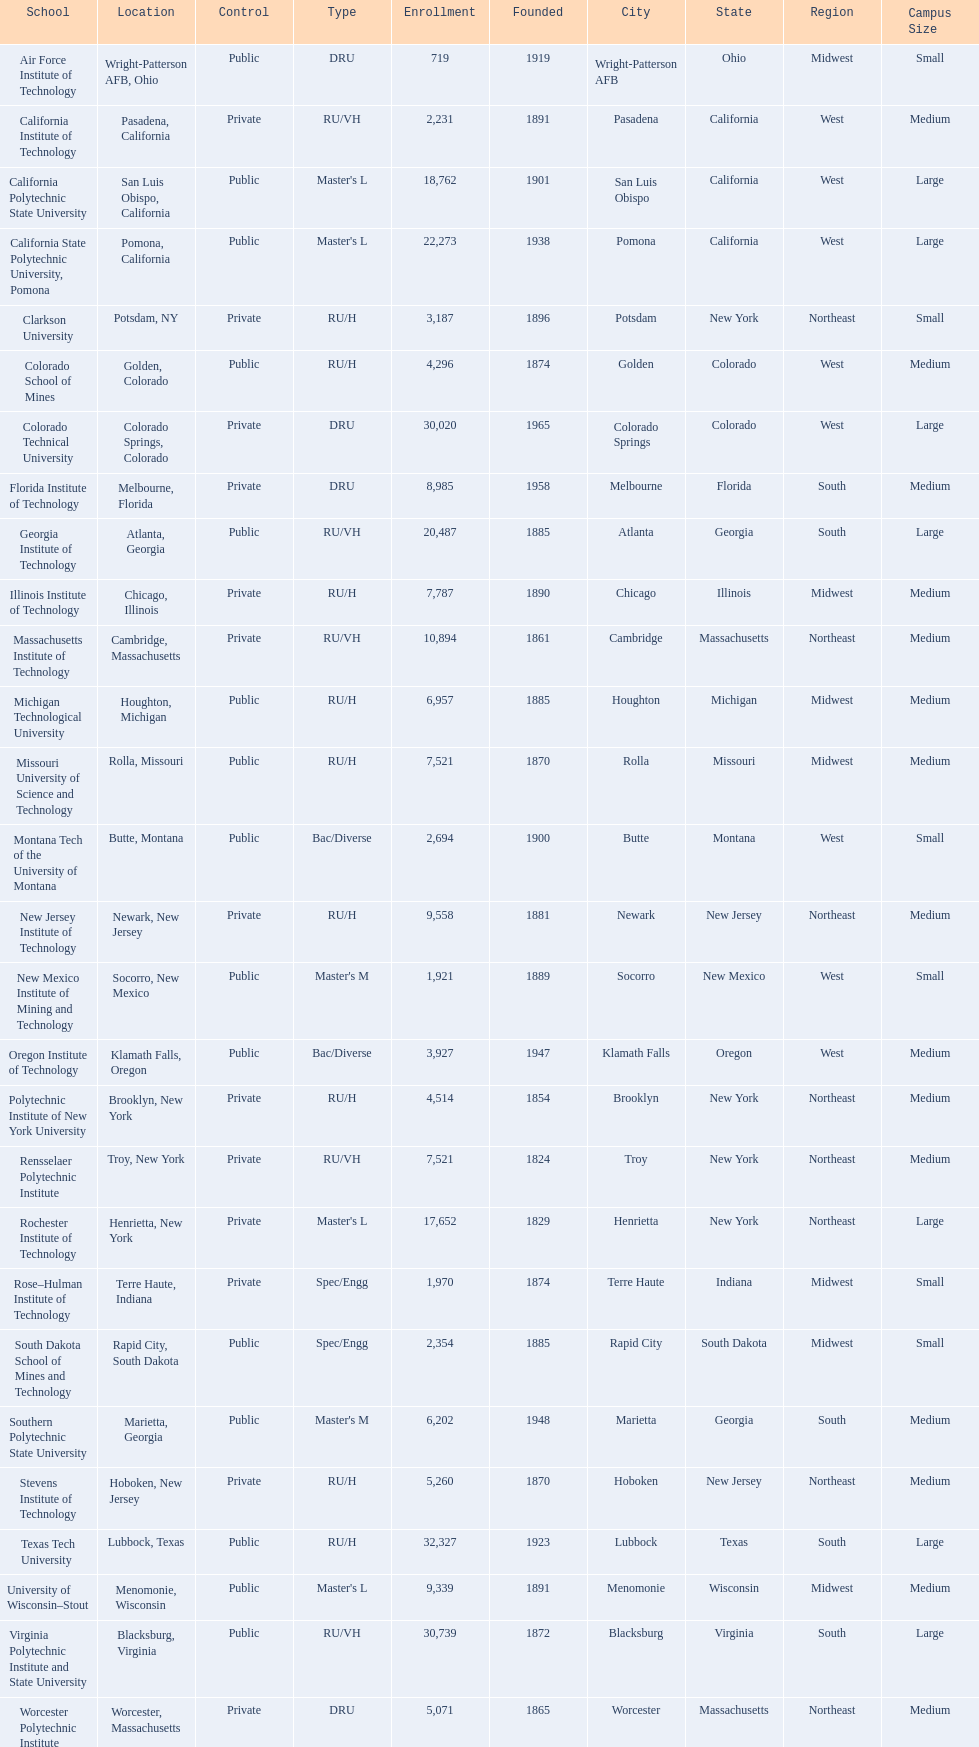What technical universities are in the united states? Air Force Institute of Technology, California Institute of Technology, California Polytechnic State University, California State Polytechnic University, Pomona, Clarkson University, Colorado School of Mines, Colorado Technical University, Florida Institute of Technology, Georgia Institute of Technology, Illinois Institute of Technology, Massachusetts Institute of Technology, Michigan Technological University, Missouri University of Science and Technology, Montana Tech of the University of Montana, New Jersey Institute of Technology, New Mexico Institute of Mining and Technology, Oregon Institute of Technology, Polytechnic Institute of New York University, Rensselaer Polytechnic Institute, Rochester Institute of Technology, Rose–Hulman Institute of Technology, South Dakota School of Mines and Technology, Southern Polytechnic State University, Stevens Institute of Technology, Texas Tech University, University of Wisconsin–Stout, Virginia Polytechnic Institute and State University, Worcester Polytechnic Institute. Which has the highest enrollment? Texas Tech University. 